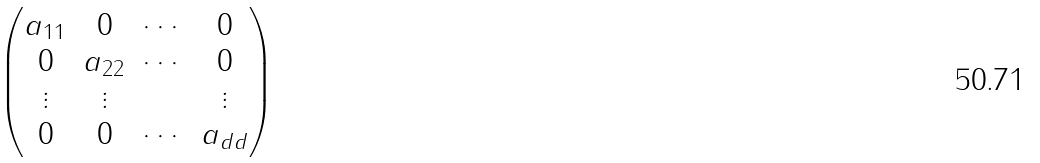<formula> <loc_0><loc_0><loc_500><loc_500>\begin{pmatrix} a _ { 1 1 } & 0 & \cdots & 0 \\ 0 & a _ { 2 2 } & \cdots & 0 \\ \vdots & \vdots & & \vdots \\ 0 & 0 & \cdots & a _ { d d } \end{pmatrix}</formula> 